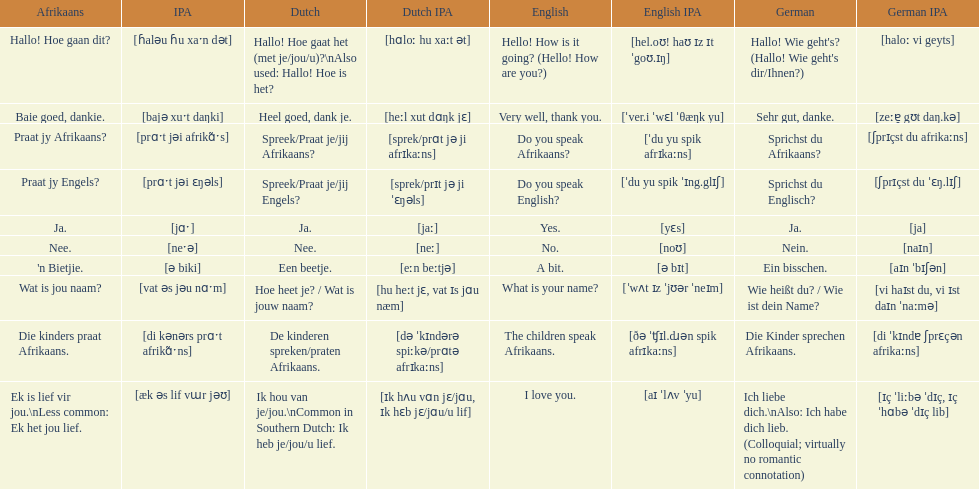How do you say 'do you speak afrikaans?' in afrikaans? Praat jy Afrikaans?. 